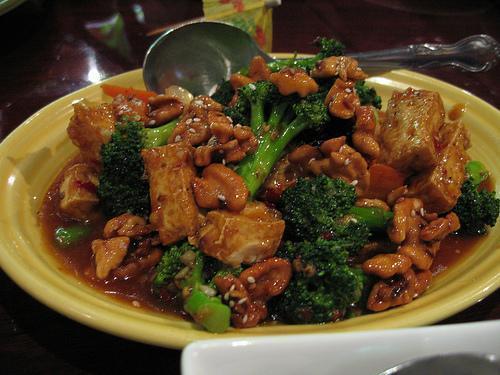How many spoons are in dish?
Give a very brief answer. 1. How many dishes of food are on the table?
Give a very brief answer. 1. 